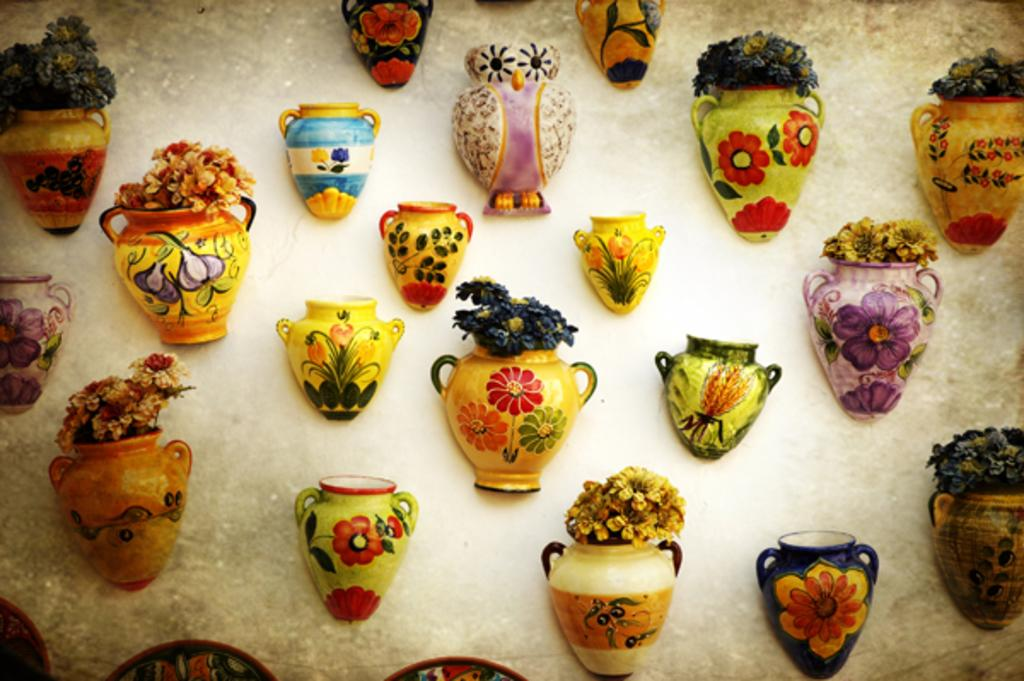What is present on the wall in the image? There is a wall in the image with sculptures of flower pots. What can be observed about the sculptures? The sculptures have different kinds of paintings on them. How does the car affect the friction between the sculptures in the image? There is no car present in the image, so it cannot affect the friction between the sculptures. 